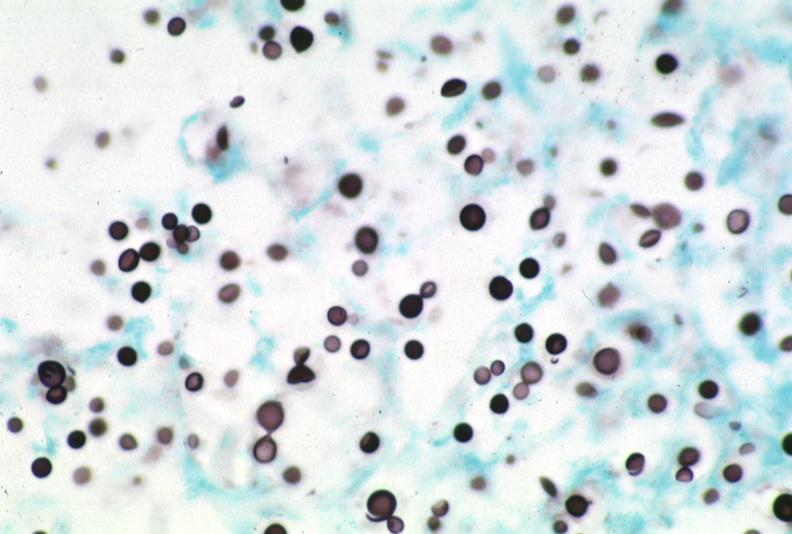what does this image show?
Answer the question using a single word or phrase. Lymph node 